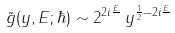<formula> <loc_0><loc_0><loc_500><loc_500>\tilde { g } ( y , E ; \hbar { ) } \sim 2 ^ { 2 i \frac { E } { } } \, y ^ { \frac { 1 } { 2 } - 2 i \frac { E } { } }</formula> 